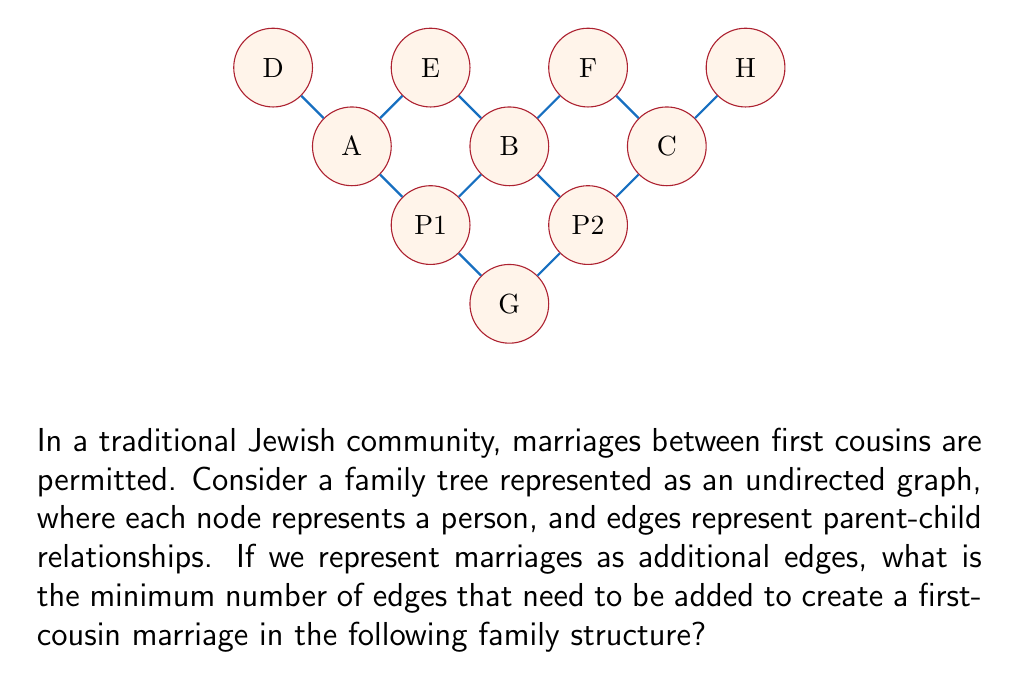Can you answer this question? Let's approach this step-by-step:

1) First, we need to understand what constitutes a first-cousin relationship in this graph. First cousins are the children of siblings.

2) In this graph, siblings are represented by nodes that share a parent. For example, A, B, and C are siblings as they all connect to P1 or P2.

3) The children of A, B, and C (i.e., D, E, F, and H) are first cousins to each other.

4) To create a first-cousin marriage, we need to add an edge between any two of these first cousins.

5) The minimum number of edges needed to create such a marriage is 1.

6) For example, we could add an edge between D and F, or E and H, or any other pair of first cousins.

7) Mathematically, if we denote the set of first cousins as $C = \{D, E, F, H\}$, we need to add an edge $e = (x, y)$ where $x, y \in C$ and $x \neq y$.

8) The number of possible first-cousin marriages in this graph is $\binom{4}{2} = 6$, but we only need to add one of these edges to create a first-cousin marriage.

Therefore, the minimum number of edges that need to be added is 1.
Answer: 1 